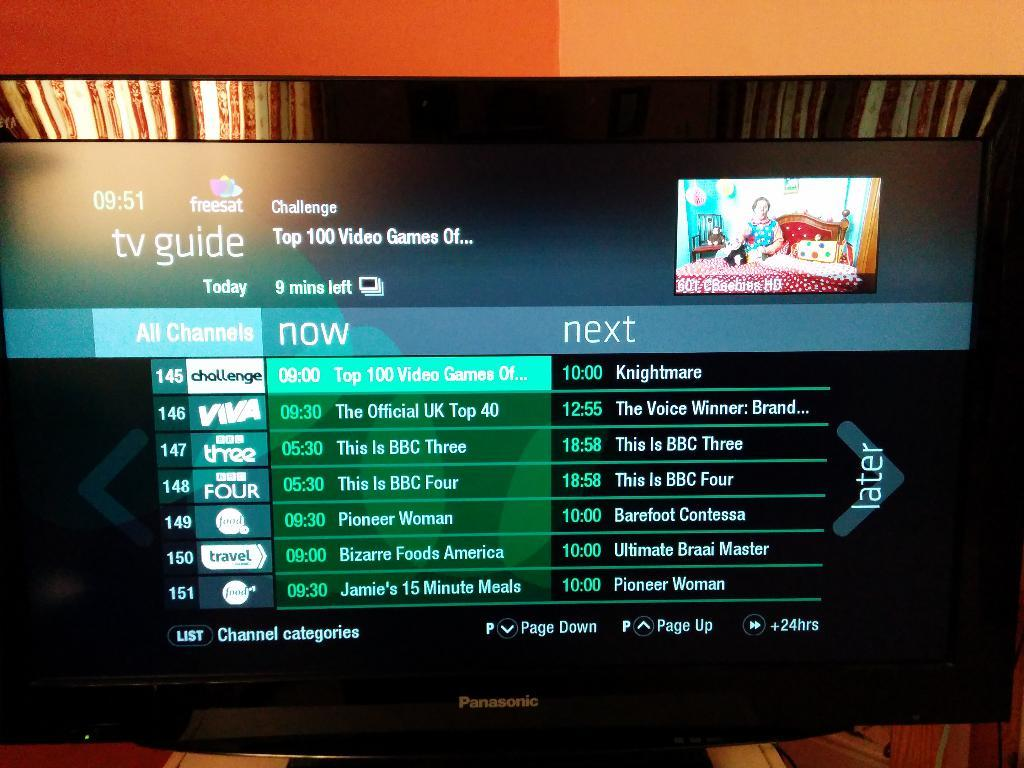<image>
Offer a succinct explanation of the picture presented. A tv that is displaying a tv guide with various shows 